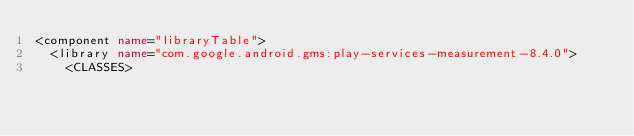Convert code to text. <code><loc_0><loc_0><loc_500><loc_500><_XML_><component name="libraryTable">
  <library name="com.google.android.gms:play-services-measurement-8.4.0">
    <CLASSES></code> 